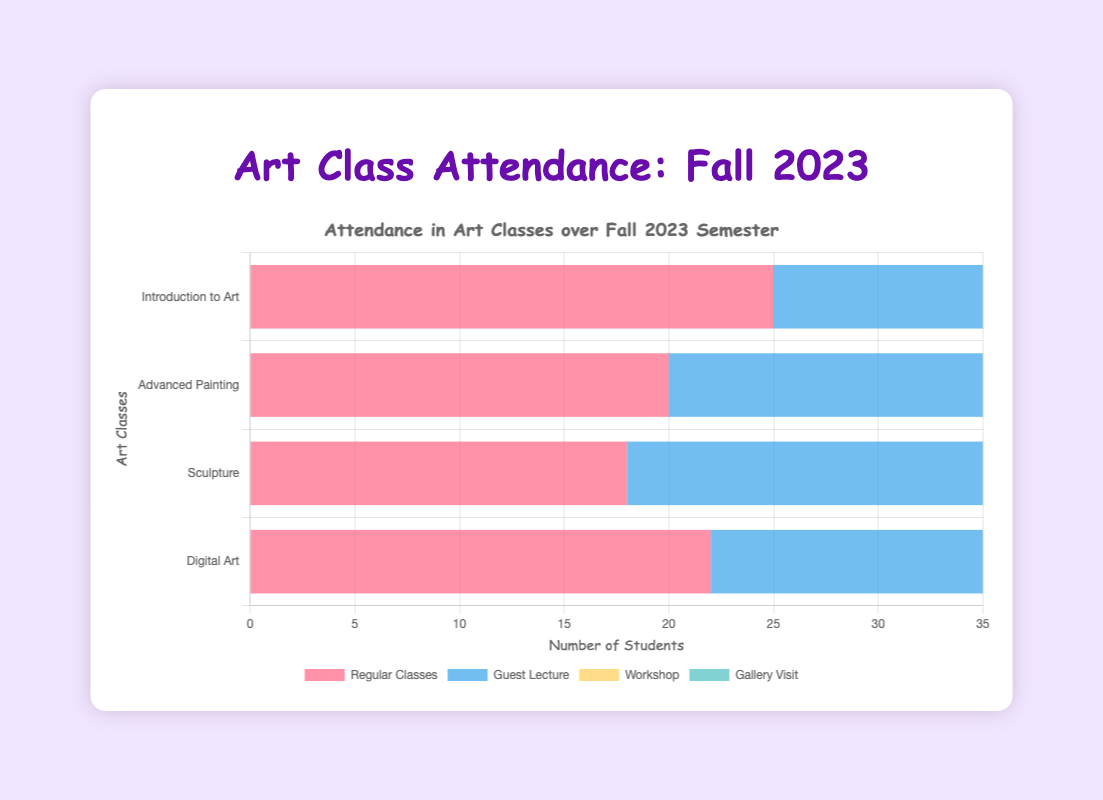What's the total attendance for "Introduction to Art" in all sessions? Sum the attendance counts for each session in "Introduction to Art" (25 + 30 + 28 + 27). The sum is 110.
Answer: 110 Which session type had the highest attendance in the "Digital Art" class? Compare the attendance counts for each session in the "Digital Art" class: Regular Classes (22), Guest Lecture (26), Workshop (25), Gallery Visit (23). The highest attendance is for the Guest Lecture.
Answer: Guest Lecture Which class had the lowest average attendance across all sessions? Compute the average attendance for each class, then compare:
- Introduction to Art: (25 + 30 + 28 + 27)/4 = 27.5
- Advanced Painting: (20 + 23 + 22 + 24)/4 = 22.25
- Sculpture: (18 + 20 + 21 + 19)/4 = 19.5
- Digital Art: (22 + 26 + 25 + 23)/4 = 24
The lowest average is for Sculpture.
Answer: Sculpture Which session type generally saw an increase in attendance compared to Regular Classes? Compare each class's Regular Classes attendance with the same class's specific session types:
- Introduction to Art: All special sessions have more attendees than Regular Classes.
- Advanced Painting: Guest Lecture, Workshop, and Gallery Visit have more attendees.
- Sculpture: All special sessions have more attendees.
- Digital Art: All special sessions have more attendees.
Hence, all session types see an increase.
Answer: All special sessions Is there a session type where all classes have uniform attendance trends compared to their respective Regular Classes? Compare the attendance of each special event in all classes to their corresponding Regular Classes:
- Guest Lecture: Intro to Art (+5), Adv. Painting (+3), Sculpture (+2), Digital Art (+4)
- Workshop: Intro to Art (+3), Adv. Painting (+2), Sculpture (+3), Digital Art (+3)
- Gallery Visit has varied changes.
Both Guest Lectures and Workshops show consistent rise across all classes.
Answer: Guest Lecture, Workshop 